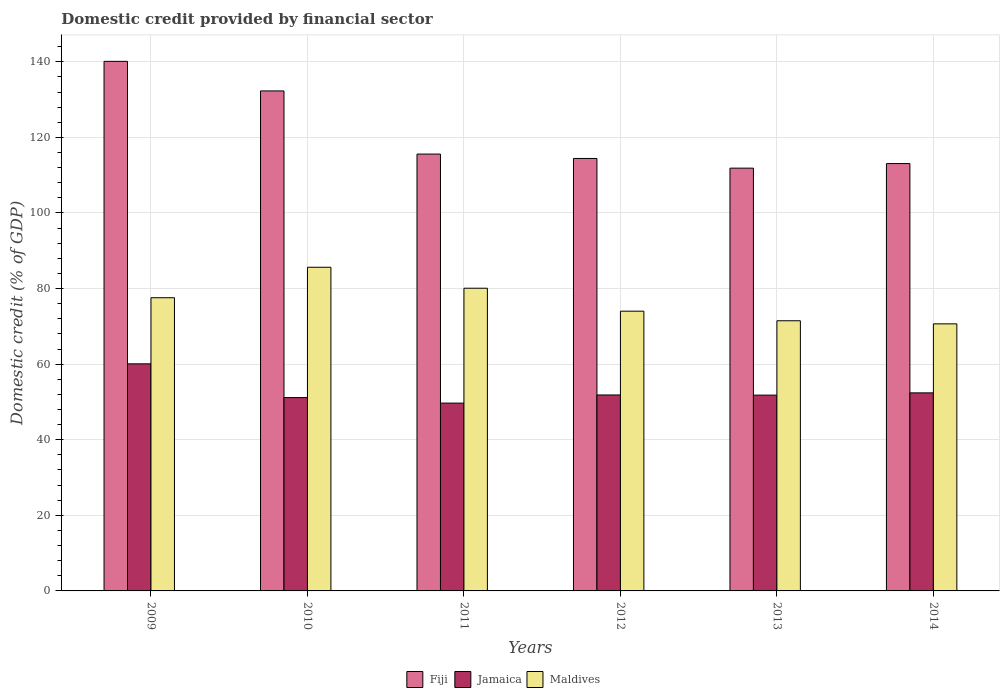How many groups of bars are there?
Your answer should be very brief. 6. What is the domestic credit in Fiji in 2012?
Make the answer very short. 114.43. Across all years, what is the maximum domestic credit in Jamaica?
Keep it short and to the point. 60.08. Across all years, what is the minimum domestic credit in Fiji?
Your answer should be compact. 111.86. In which year was the domestic credit in Jamaica minimum?
Provide a short and direct response. 2011. What is the total domestic credit in Maldives in the graph?
Your answer should be very brief. 459.47. What is the difference between the domestic credit in Fiji in 2010 and that in 2013?
Your answer should be very brief. 20.43. What is the difference between the domestic credit in Jamaica in 2011 and the domestic credit in Fiji in 2012?
Ensure brevity in your answer.  -64.73. What is the average domestic credit in Jamaica per year?
Make the answer very short. 52.83. In the year 2014, what is the difference between the domestic credit in Jamaica and domestic credit in Maldives?
Keep it short and to the point. -18.26. In how many years, is the domestic credit in Fiji greater than 24 %?
Make the answer very short. 6. What is the ratio of the domestic credit in Maldives in 2011 to that in 2013?
Provide a succinct answer. 1.12. Is the domestic credit in Maldives in 2009 less than that in 2012?
Offer a very short reply. No. Is the difference between the domestic credit in Jamaica in 2011 and 2013 greater than the difference between the domestic credit in Maldives in 2011 and 2013?
Ensure brevity in your answer.  No. What is the difference between the highest and the second highest domestic credit in Fiji?
Keep it short and to the point. 7.82. What is the difference between the highest and the lowest domestic credit in Jamaica?
Ensure brevity in your answer.  10.39. What does the 2nd bar from the left in 2009 represents?
Offer a very short reply. Jamaica. What does the 2nd bar from the right in 2011 represents?
Give a very brief answer. Jamaica. Is it the case that in every year, the sum of the domestic credit in Maldives and domestic credit in Jamaica is greater than the domestic credit in Fiji?
Offer a very short reply. No. How many bars are there?
Provide a succinct answer. 18. What is the difference between two consecutive major ticks on the Y-axis?
Keep it short and to the point. 20. Are the values on the major ticks of Y-axis written in scientific E-notation?
Offer a terse response. No. Does the graph contain any zero values?
Offer a very short reply. No. Does the graph contain grids?
Provide a short and direct response. Yes. Where does the legend appear in the graph?
Provide a short and direct response. Bottom center. How many legend labels are there?
Offer a terse response. 3. How are the legend labels stacked?
Offer a very short reply. Horizontal. What is the title of the graph?
Your answer should be very brief. Domestic credit provided by financial sector. What is the label or title of the Y-axis?
Give a very brief answer. Domestic credit (% of GDP). What is the Domestic credit (% of GDP) in Fiji in 2009?
Make the answer very short. 140.12. What is the Domestic credit (% of GDP) in Jamaica in 2009?
Your answer should be very brief. 60.08. What is the Domestic credit (% of GDP) of Maldives in 2009?
Ensure brevity in your answer.  77.58. What is the Domestic credit (% of GDP) of Fiji in 2010?
Ensure brevity in your answer.  132.3. What is the Domestic credit (% of GDP) in Jamaica in 2010?
Offer a terse response. 51.16. What is the Domestic credit (% of GDP) of Maldives in 2010?
Offer a terse response. 85.64. What is the Domestic credit (% of GDP) of Fiji in 2011?
Ensure brevity in your answer.  115.59. What is the Domestic credit (% of GDP) of Jamaica in 2011?
Ensure brevity in your answer.  49.7. What is the Domestic credit (% of GDP) in Maldives in 2011?
Keep it short and to the point. 80.09. What is the Domestic credit (% of GDP) of Fiji in 2012?
Keep it short and to the point. 114.43. What is the Domestic credit (% of GDP) of Jamaica in 2012?
Your answer should be compact. 51.85. What is the Domestic credit (% of GDP) in Maldives in 2012?
Your response must be concise. 74.02. What is the Domestic credit (% of GDP) in Fiji in 2013?
Offer a very short reply. 111.86. What is the Domestic credit (% of GDP) in Jamaica in 2013?
Your response must be concise. 51.81. What is the Domestic credit (% of GDP) in Maldives in 2013?
Make the answer very short. 71.48. What is the Domestic credit (% of GDP) of Fiji in 2014?
Give a very brief answer. 113.07. What is the Domestic credit (% of GDP) of Jamaica in 2014?
Provide a short and direct response. 52.4. What is the Domestic credit (% of GDP) of Maldives in 2014?
Offer a very short reply. 70.67. Across all years, what is the maximum Domestic credit (% of GDP) of Fiji?
Offer a terse response. 140.12. Across all years, what is the maximum Domestic credit (% of GDP) of Jamaica?
Your answer should be compact. 60.08. Across all years, what is the maximum Domestic credit (% of GDP) of Maldives?
Offer a very short reply. 85.64. Across all years, what is the minimum Domestic credit (% of GDP) of Fiji?
Your response must be concise. 111.86. Across all years, what is the minimum Domestic credit (% of GDP) of Jamaica?
Give a very brief answer. 49.7. Across all years, what is the minimum Domestic credit (% of GDP) in Maldives?
Your answer should be compact. 70.67. What is the total Domestic credit (% of GDP) of Fiji in the graph?
Ensure brevity in your answer.  727.36. What is the total Domestic credit (% of GDP) in Jamaica in the graph?
Give a very brief answer. 317. What is the total Domestic credit (% of GDP) of Maldives in the graph?
Give a very brief answer. 459.47. What is the difference between the Domestic credit (% of GDP) in Fiji in 2009 and that in 2010?
Make the answer very short. 7.82. What is the difference between the Domestic credit (% of GDP) of Jamaica in 2009 and that in 2010?
Provide a succinct answer. 8.93. What is the difference between the Domestic credit (% of GDP) in Maldives in 2009 and that in 2010?
Give a very brief answer. -8.06. What is the difference between the Domestic credit (% of GDP) in Fiji in 2009 and that in 2011?
Your answer should be very brief. 24.53. What is the difference between the Domestic credit (% of GDP) of Jamaica in 2009 and that in 2011?
Provide a succinct answer. 10.39. What is the difference between the Domestic credit (% of GDP) in Maldives in 2009 and that in 2011?
Your answer should be very brief. -2.51. What is the difference between the Domestic credit (% of GDP) of Fiji in 2009 and that in 2012?
Offer a terse response. 25.69. What is the difference between the Domestic credit (% of GDP) in Jamaica in 2009 and that in 2012?
Ensure brevity in your answer.  8.23. What is the difference between the Domestic credit (% of GDP) in Maldives in 2009 and that in 2012?
Ensure brevity in your answer.  3.56. What is the difference between the Domestic credit (% of GDP) of Fiji in 2009 and that in 2013?
Your answer should be compact. 28.26. What is the difference between the Domestic credit (% of GDP) in Jamaica in 2009 and that in 2013?
Offer a terse response. 8.28. What is the difference between the Domestic credit (% of GDP) of Maldives in 2009 and that in 2013?
Provide a succinct answer. 6.09. What is the difference between the Domestic credit (% of GDP) of Fiji in 2009 and that in 2014?
Your response must be concise. 27.05. What is the difference between the Domestic credit (% of GDP) of Jamaica in 2009 and that in 2014?
Give a very brief answer. 7.68. What is the difference between the Domestic credit (% of GDP) of Maldives in 2009 and that in 2014?
Provide a short and direct response. 6.91. What is the difference between the Domestic credit (% of GDP) of Fiji in 2010 and that in 2011?
Offer a terse response. 16.71. What is the difference between the Domestic credit (% of GDP) of Jamaica in 2010 and that in 2011?
Offer a very short reply. 1.46. What is the difference between the Domestic credit (% of GDP) in Maldives in 2010 and that in 2011?
Give a very brief answer. 5.55. What is the difference between the Domestic credit (% of GDP) in Fiji in 2010 and that in 2012?
Provide a succinct answer. 17.87. What is the difference between the Domestic credit (% of GDP) of Jamaica in 2010 and that in 2012?
Your answer should be very brief. -0.69. What is the difference between the Domestic credit (% of GDP) in Maldives in 2010 and that in 2012?
Offer a very short reply. 11.62. What is the difference between the Domestic credit (% of GDP) in Fiji in 2010 and that in 2013?
Provide a short and direct response. 20.43. What is the difference between the Domestic credit (% of GDP) in Jamaica in 2010 and that in 2013?
Your response must be concise. -0.65. What is the difference between the Domestic credit (% of GDP) in Maldives in 2010 and that in 2013?
Your answer should be compact. 14.16. What is the difference between the Domestic credit (% of GDP) of Fiji in 2010 and that in 2014?
Offer a very short reply. 19.22. What is the difference between the Domestic credit (% of GDP) of Jamaica in 2010 and that in 2014?
Provide a succinct answer. -1.25. What is the difference between the Domestic credit (% of GDP) of Maldives in 2010 and that in 2014?
Your answer should be compact. 14.97. What is the difference between the Domestic credit (% of GDP) in Fiji in 2011 and that in 2012?
Make the answer very short. 1.16. What is the difference between the Domestic credit (% of GDP) in Jamaica in 2011 and that in 2012?
Ensure brevity in your answer.  -2.15. What is the difference between the Domestic credit (% of GDP) of Maldives in 2011 and that in 2012?
Your answer should be very brief. 6.07. What is the difference between the Domestic credit (% of GDP) in Fiji in 2011 and that in 2013?
Provide a short and direct response. 3.73. What is the difference between the Domestic credit (% of GDP) of Jamaica in 2011 and that in 2013?
Your response must be concise. -2.11. What is the difference between the Domestic credit (% of GDP) of Maldives in 2011 and that in 2013?
Make the answer very short. 8.61. What is the difference between the Domestic credit (% of GDP) of Fiji in 2011 and that in 2014?
Offer a terse response. 2.51. What is the difference between the Domestic credit (% of GDP) in Jamaica in 2011 and that in 2014?
Give a very brief answer. -2.71. What is the difference between the Domestic credit (% of GDP) of Maldives in 2011 and that in 2014?
Give a very brief answer. 9.42. What is the difference between the Domestic credit (% of GDP) of Fiji in 2012 and that in 2013?
Your answer should be compact. 2.57. What is the difference between the Domestic credit (% of GDP) in Jamaica in 2012 and that in 2013?
Provide a succinct answer. 0.04. What is the difference between the Domestic credit (% of GDP) in Maldives in 2012 and that in 2013?
Offer a terse response. 2.53. What is the difference between the Domestic credit (% of GDP) of Fiji in 2012 and that in 2014?
Provide a short and direct response. 1.36. What is the difference between the Domestic credit (% of GDP) in Jamaica in 2012 and that in 2014?
Offer a very short reply. -0.55. What is the difference between the Domestic credit (% of GDP) of Maldives in 2012 and that in 2014?
Offer a very short reply. 3.35. What is the difference between the Domestic credit (% of GDP) in Fiji in 2013 and that in 2014?
Offer a very short reply. -1.21. What is the difference between the Domestic credit (% of GDP) in Jamaica in 2013 and that in 2014?
Offer a terse response. -0.6. What is the difference between the Domestic credit (% of GDP) in Maldives in 2013 and that in 2014?
Provide a succinct answer. 0.82. What is the difference between the Domestic credit (% of GDP) in Fiji in 2009 and the Domestic credit (% of GDP) in Jamaica in 2010?
Keep it short and to the point. 88.96. What is the difference between the Domestic credit (% of GDP) of Fiji in 2009 and the Domestic credit (% of GDP) of Maldives in 2010?
Your answer should be very brief. 54.48. What is the difference between the Domestic credit (% of GDP) in Jamaica in 2009 and the Domestic credit (% of GDP) in Maldives in 2010?
Make the answer very short. -25.55. What is the difference between the Domestic credit (% of GDP) in Fiji in 2009 and the Domestic credit (% of GDP) in Jamaica in 2011?
Your answer should be very brief. 90.42. What is the difference between the Domestic credit (% of GDP) in Fiji in 2009 and the Domestic credit (% of GDP) in Maldives in 2011?
Give a very brief answer. 60.03. What is the difference between the Domestic credit (% of GDP) of Jamaica in 2009 and the Domestic credit (% of GDP) of Maldives in 2011?
Provide a succinct answer. -20. What is the difference between the Domestic credit (% of GDP) of Fiji in 2009 and the Domestic credit (% of GDP) of Jamaica in 2012?
Your response must be concise. 88.27. What is the difference between the Domestic credit (% of GDP) in Fiji in 2009 and the Domestic credit (% of GDP) in Maldives in 2012?
Provide a short and direct response. 66.1. What is the difference between the Domestic credit (% of GDP) in Jamaica in 2009 and the Domestic credit (% of GDP) in Maldives in 2012?
Your answer should be very brief. -13.93. What is the difference between the Domestic credit (% of GDP) in Fiji in 2009 and the Domestic credit (% of GDP) in Jamaica in 2013?
Make the answer very short. 88.31. What is the difference between the Domestic credit (% of GDP) in Fiji in 2009 and the Domestic credit (% of GDP) in Maldives in 2013?
Make the answer very short. 68.64. What is the difference between the Domestic credit (% of GDP) in Jamaica in 2009 and the Domestic credit (% of GDP) in Maldives in 2013?
Provide a succinct answer. -11.4. What is the difference between the Domestic credit (% of GDP) in Fiji in 2009 and the Domestic credit (% of GDP) in Jamaica in 2014?
Provide a short and direct response. 87.72. What is the difference between the Domestic credit (% of GDP) of Fiji in 2009 and the Domestic credit (% of GDP) of Maldives in 2014?
Give a very brief answer. 69.45. What is the difference between the Domestic credit (% of GDP) in Jamaica in 2009 and the Domestic credit (% of GDP) in Maldives in 2014?
Ensure brevity in your answer.  -10.58. What is the difference between the Domestic credit (% of GDP) of Fiji in 2010 and the Domestic credit (% of GDP) of Jamaica in 2011?
Provide a succinct answer. 82.6. What is the difference between the Domestic credit (% of GDP) of Fiji in 2010 and the Domestic credit (% of GDP) of Maldives in 2011?
Keep it short and to the point. 52.21. What is the difference between the Domestic credit (% of GDP) in Jamaica in 2010 and the Domestic credit (% of GDP) in Maldives in 2011?
Offer a very short reply. -28.93. What is the difference between the Domestic credit (% of GDP) of Fiji in 2010 and the Domestic credit (% of GDP) of Jamaica in 2012?
Provide a succinct answer. 80.45. What is the difference between the Domestic credit (% of GDP) in Fiji in 2010 and the Domestic credit (% of GDP) in Maldives in 2012?
Provide a short and direct response. 58.28. What is the difference between the Domestic credit (% of GDP) in Jamaica in 2010 and the Domestic credit (% of GDP) in Maldives in 2012?
Make the answer very short. -22.86. What is the difference between the Domestic credit (% of GDP) of Fiji in 2010 and the Domestic credit (% of GDP) of Jamaica in 2013?
Provide a succinct answer. 80.49. What is the difference between the Domestic credit (% of GDP) of Fiji in 2010 and the Domestic credit (% of GDP) of Maldives in 2013?
Your answer should be compact. 60.81. What is the difference between the Domestic credit (% of GDP) of Jamaica in 2010 and the Domestic credit (% of GDP) of Maldives in 2013?
Ensure brevity in your answer.  -20.33. What is the difference between the Domestic credit (% of GDP) of Fiji in 2010 and the Domestic credit (% of GDP) of Jamaica in 2014?
Provide a short and direct response. 79.89. What is the difference between the Domestic credit (% of GDP) in Fiji in 2010 and the Domestic credit (% of GDP) in Maldives in 2014?
Provide a succinct answer. 61.63. What is the difference between the Domestic credit (% of GDP) in Jamaica in 2010 and the Domestic credit (% of GDP) in Maldives in 2014?
Provide a succinct answer. -19.51. What is the difference between the Domestic credit (% of GDP) in Fiji in 2011 and the Domestic credit (% of GDP) in Jamaica in 2012?
Keep it short and to the point. 63.74. What is the difference between the Domestic credit (% of GDP) of Fiji in 2011 and the Domestic credit (% of GDP) of Maldives in 2012?
Offer a terse response. 41.57. What is the difference between the Domestic credit (% of GDP) in Jamaica in 2011 and the Domestic credit (% of GDP) in Maldives in 2012?
Provide a succinct answer. -24.32. What is the difference between the Domestic credit (% of GDP) in Fiji in 2011 and the Domestic credit (% of GDP) in Jamaica in 2013?
Offer a terse response. 63.78. What is the difference between the Domestic credit (% of GDP) of Fiji in 2011 and the Domestic credit (% of GDP) of Maldives in 2013?
Give a very brief answer. 44.1. What is the difference between the Domestic credit (% of GDP) in Jamaica in 2011 and the Domestic credit (% of GDP) in Maldives in 2013?
Your answer should be compact. -21.79. What is the difference between the Domestic credit (% of GDP) in Fiji in 2011 and the Domestic credit (% of GDP) in Jamaica in 2014?
Offer a terse response. 63.18. What is the difference between the Domestic credit (% of GDP) in Fiji in 2011 and the Domestic credit (% of GDP) in Maldives in 2014?
Provide a succinct answer. 44.92. What is the difference between the Domestic credit (% of GDP) in Jamaica in 2011 and the Domestic credit (% of GDP) in Maldives in 2014?
Offer a very short reply. -20.97. What is the difference between the Domestic credit (% of GDP) of Fiji in 2012 and the Domestic credit (% of GDP) of Jamaica in 2013?
Your answer should be compact. 62.62. What is the difference between the Domestic credit (% of GDP) in Fiji in 2012 and the Domestic credit (% of GDP) in Maldives in 2013?
Your answer should be very brief. 42.95. What is the difference between the Domestic credit (% of GDP) in Jamaica in 2012 and the Domestic credit (% of GDP) in Maldives in 2013?
Your answer should be very brief. -19.63. What is the difference between the Domestic credit (% of GDP) of Fiji in 2012 and the Domestic credit (% of GDP) of Jamaica in 2014?
Offer a terse response. 62.02. What is the difference between the Domestic credit (% of GDP) of Fiji in 2012 and the Domestic credit (% of GDP) of Maldives in 2014?
Provide a succinct answer. 43.76. What is the difference between the Domestic credit (% of GDP) in Jamaica in 2012 and the Domestic credit (% of GDP) in Maldives in 2014?
Your answer should be compact. -18.82. What is the difference between the Domestic credit (% of GDP) in Fiji in 2013 and the Domestic credit (% of GDP) in Jamaica in 2014?
Give a very brief answer. 59.46. What is the difference between the Domestic credit (% of GDP) of Fiji in 2013 and the Domestic credit (% of GDP) of Maldives in 2014?
Provide a succinct answer. 41.19. What is the difference between the Domestic credit (% of GDP) in Jamaica in 2013 and the Domestic credit (% of GDP) in Maldives in 2014?
Your answer should be compact. -18.86. What is the average Domestic credit (% of GDP) in Fiji per year?
Ensure brevity in your answer.  121.23. What is the average Domestic credit (% of GDP) of Jamaica per year?
Make the answer very short. 52.83. What is the average Domestic credit (% of GDP) of Maldives per year?
Provide a short and direct response. 76.58. In the year 2009, what is the difference between the Domestic credit (% of GDP) of Fiji and Domestic credit (% of GDP) of Jamaica?
Keep it short and to the point. 80.04. In the year 2009, what is the difference between the Domestic credit (% of GDP) of Fiji and Domestic credit (% of GDP) of Maldives?
Keep it short and to the point. 62.54. In the year 2009, what is the difference between the Domestic credit (% of GDP) in Jamaica and Domestic credit (% of GDP) in Maldives?
Keep it short and to the point. -17.49. In the year 2010, what is the difference between the Domestic credit (% of GDP) of Fiji and Domestic credit (% of GDP) of Jamaica?
Keep it short and to the point. 81.14. In the year 2010, what is the difference between the Domestic credit (% of GDP) in Fiji and Domestic credit (% of GDP) in Maldives?
Offer a very short reply. 46.66. In the year 2010, what is the difference between the Domestic credit (% of GDP) in Jamaica and Domestic credit (% of GDP) in Maldives?
Give a very brief answer. -34.48. In the year 2011, what is the difference between the Domestic credit (% of GDP) of Fiji and Domestic credit (% of GDP) of Jamaica?
Ensure brevity in your answer.  65.89. In the year 2011, what is the difference between the Domestic credit (% of GDP) of Fiji and Domestic credit (% of GDP) of Maldives?
Your answer should be compact. 35.5. In the year 2011, what is the difference between the Domestic credit (% of GDP) in Jamaica and Domestic credit (% of GDP) in Maldives?
Give a very brief answer. -30.39. In the year 2012, what is the difference between the Domestic credit (% of GDP) in Fiji and Domestic credit (% of GDP) in Jamaica?
Keep it short and to the point. 62.58. In the year 2012, what is the difference between the Domestic credit (% of GDP) of Fiji and Domestic credit (% of GDP) of Maldives?
Provide a succinct answer. 40.41. In the year 2012, what is the difference between the Domestic credit (% of GDP) in Jamaica and Domestic credit (% of GDP) in Maldives?
Your answer should be compact. -22.17. In the year 2013, what is the difference between the Domestic credit (% of GDP) of Fiji and Domestic credit (% of GDP) of Jamaica?
Make the answer very short. 60.05. In the year 2013, what is the difference between the Domestic credit (% of GDP) of Fiji and Domestic credit (% of GDP) of Maldives?
Your response must be concise. 40.38. In the year 2013, what is the difference between the Domestic credit (% of GDP) of Jamaica and Domestic credit (% of GDP) of Maldives?
Your response must be concise. -19.68. In the year 2014, what is the difference between the Domestic credit (% of GDP) in Fiji and Domestic credit (% of GDP) in Jamaica?
Offer a very short reply. 60.67. In the year 2014, what is the difference between the Domestic credit (% of GDP) of Fiji and Domestic credit (% of GDP) of Maldives?
Make the answer very short. 42.41. In the year 2014, what is the difference between the Domestic credit (% of GDP) in Jamaica and Domestic credit (% of GDP) in Maldives?
Your response must be concise. -18.26. What is the ratio of the Domestic credit (% of GDP) of Fiji in 2009 to that in 2010?
Your answer should be compact. 1.06. What is the ratio of the Domestic credit (% of GDP) in Jamaica in 2009 to that in 2010?
Offer a terse response. 1.17. What is the ratio of the Domestic credit (% of GDP) of Maldives in 2009 to that in 2010?
Make the answer very short. 0.91. What is the ratio of the Domestic credit (% of GDP) in Fiji in 2009 to that in 2011?
Ensure brevity in your answer.  1.21. What is the ratio of the Domestic credit (% of GDP) of Jamaica in 2009 to that in 2011?
Offer a terse response. 1.21. What is the ratio of the Domestic credit (% of GDP) of Maldives in 2009 to that in 2011?
Provide a short and direct response. 0.97. What is the ratio of the Domestic credit (% of GDP) of Fiji in 2009 to that in 2012?
Your response must be concise. 1.22. What is the ratio of the Domestic credit (% of GDP) of Jamaica in 2009 to that in 2012?
Make the answer very short. 1.16. What is the ratio of the Domestic credit (% of GDP) in Maldives in 2009 to that in 2012?
Make the answer very short. 1.05. What is the ratio of the Domestic credit (% of GDP) in Fiji in 2009 to that in 2013?
Offer a very short reply. 1.25. What is the ratio of the Domestic credit (% of GDP) of Jamaica in 2009 to that in 2013?
Offer a very short reply. 1.16. What is the ratio of the Domestic credit (% of GDP) in Maldives in 2009 to that in 2013?
Offer a very short reply. 1.09. What is the ratio of the Domestic credit (% of GDP) of Fiji in 2009 to that in 2014?
Your answer should be compact. 1.24. What is the ratio of the Domestic credit (% of GDP) in Jamaica in 2009 to that in 2014?
Ensure brevity in your answer.  1.15. What is the ratio of the Domestic credit (% of GDP) in Maldives in 2009 to that in 2014?
Your answer should be very brief. 1.1. What is the ratio of the Domestic credit (% of GDP) in Fiji in 2010 to that in 2011?
Offer a terse response. 1.14. What is the ratio of the Domestic credit (% of GDP) in Jamaica in 2010 to that in 2011?
Make the answer very short. 1.03. What is the ratio of the Domestic credit (% of GDP) of Maldives in 2010 to that in 2011?
Give a very brief answer. 1.07. What is the ratio of the Domestic credit (% of GDP) of Fiji in 2010 to that in 2012?
Make the answer very short. 1.16. What is the ratio of the Domestic credit (% of GDP) of Jamaica in 2010 to that in 2012?
Your answer should be compact. 0.99. What is the ratio of the Domestic credit (% of GDP) in Maldives in 2010 to that in 2012?
Keep it short and to the point. 1.16. What is the ratio of the Domestic credit (% of GDP) of Fiji in 2010 to that in 2013?
Ensure brevity in your answer.  1.18. What is the ratio of the Domestic credit (% of GDP) in Jamaica in 2010 to that in 2013?
Your answer should be very brief. 0.99. What is the ratio of the Domestic credit (% of GDP) of Maldives in 2010 to that in 2013?
Your response must be concise. 1.2. What is the ratio of the Domestic credit (% of GDP) of Fiji in 2010 to that in 2014?
Ensure brevity in your answer.  1.17. What is the ratio of the Domestic credit (% of GDP) of Jamaica in 2010 to that in 2014?
Make the answer very short. 0.98. What is the ratio of the Domestic credit (% of GDP) of Maldives in 2010 to that in 2014?
Offer a terse response. 1.21. What is the ratio of the Domestic credit (% of GDP) in Fiji in 2011 to that in 2012?
Your response must be concise. 1.01. What is the ratio of the Domestic credit (% of GDP) in Jamaica in 2011 to that in 2012?
Ensure brevity in your answer.  0.96. What is the ratio of the Domestic credit (% of GDP) of Maldives in 2011 to that in 2012?
Provide a short and direct response. 1.08. What is the ratio of the Domestic credit (% of GDP) in Jamaica in 2011 to that in 2013?
Keep it short and to the point. 0.96. What is the ratio of the Domestic credit (% of GDP) in Maldives in 2011 to that in 2013?
Your answer should be compact. 1.12. What is the ratio of the Domestic credit (% of GDP) of Fiji in 2011 to that in 2014?
Keep it short and to the point. 1.02. What is the ratio of the Domestic credit (% of GDP) of Jamaica in 2011 to that in 2014?
Make the answer very short. 0.95. What is the ratio of the Domestic credit (% of GDP) in Maldives in 2011 to that in 2014?
Make the answer very short. 1.13. What is the ratio of the Domestic credit (% of GDP) of Fiji in 2012 to that in 2013?
Your answer should be very brief. 1.02. What is the ratio of the Domestic credit (% of GDP) of Jamaica in 2012 to that in 2013?
Provide a succinct answer. 1. What is the ratio of the Domestic credit (% of GDP) of Maldives in 2012 to that in 2013?
Offer a very short reply. 1.04. What is the ratio of the Domestic credit (% of GDP) in Fiji in 2012 to that in 2014?
Keep it short and to the point. 1.01. What is the ratio of the Domestic credit (% of GDP) in Maldives in 2012 to that in 2014?
Your response must be concise. 1.05. What is the ratio of the Domestic credit (% of GDP) of Fiji in 2013 to that in 2014?
Provide a succinct answer. 0.99. What is the ratio of the Domestic credit (% of GDP) of Maldives in 2013 to that in 2014?
Give a very brief answer. 1.01. What is the difference between the highest and the second highest Domestic credit (% of GDP) of Fiji?
Offer a terse response. 7.82. What is the difference between the highest and the second highest Domestic credit (% of GDP) of Jamaica?
Provide a short and direct response. 7.68. What is the difference between the highest and the second highest Domestic credit (% of GDP) of Maldives?
Ensure brevity in your answer.  5.55. What is the difference between the highest and the lowest Domestic credit (% of GDP) of Fiji?
Keep it short and to the point. 28.26. What is the difference between the highest and the lowest Domestic credit (% of GDP) of Jamaica?
Your answer should be very brief. 10.39. What is the difference between the highest and the lowest Domestic credit (% of GDP) in Maldives?
Your answer should be compact. 14.97. 